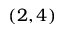Convert formula to latex. <formula><loc_0><loc_0><loc_500><loc_500>( 2 , 4 )</formula> 